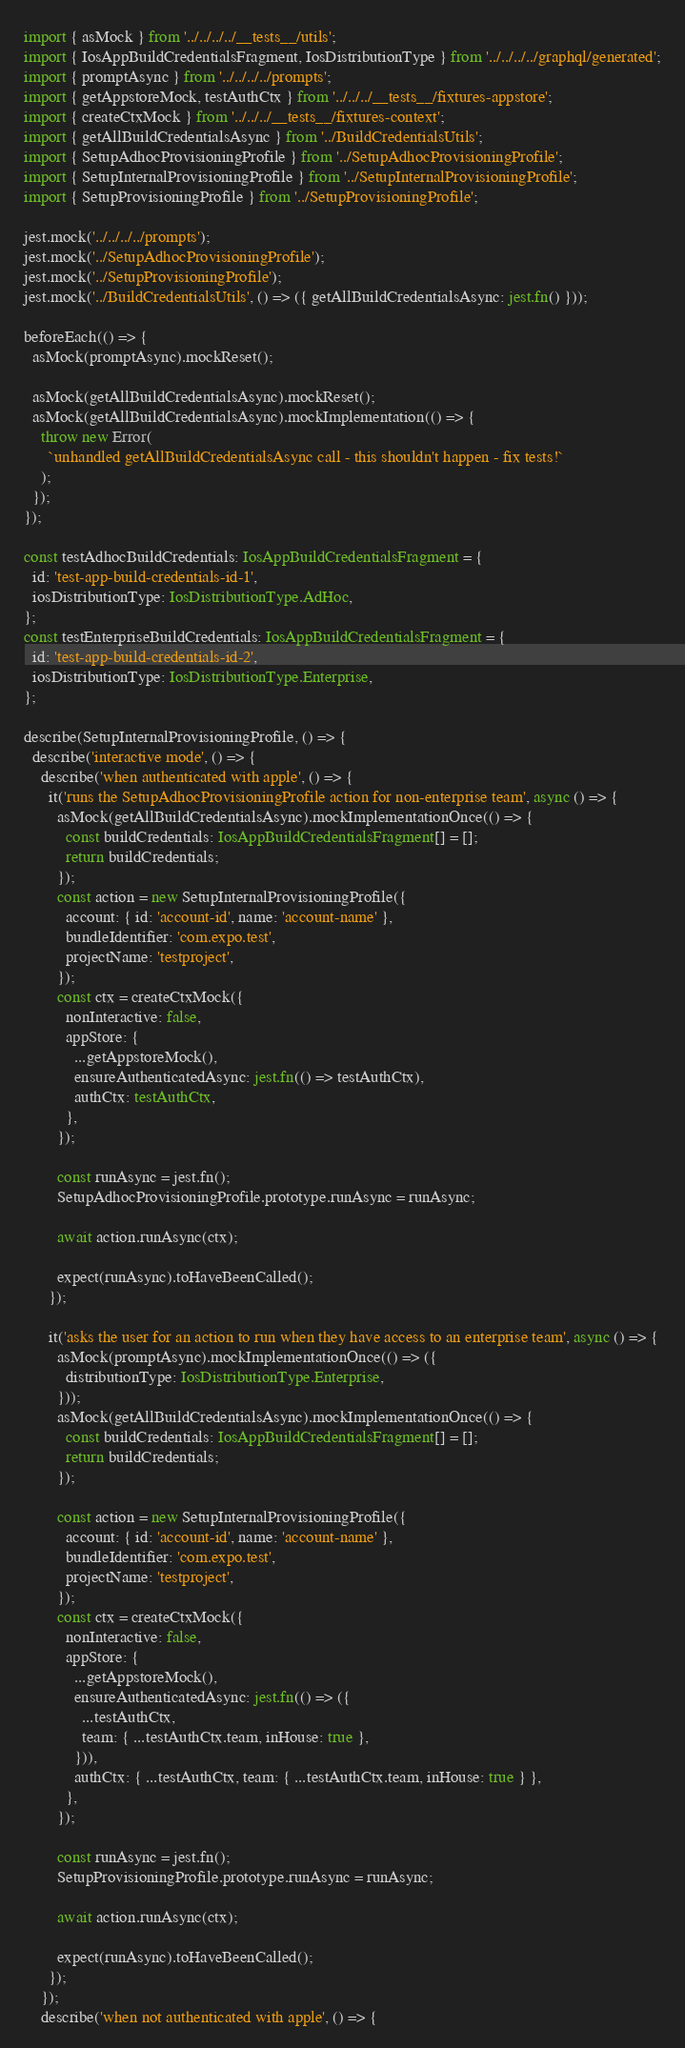Convert code to text. <code><loc_0><loc_0><loc_500><loc_500><_TypeScript_>import { asMock } from '../../../../__tests__/utils';
import { IosAppBuildCredentialsFragment, IosDistributionType } from '../../../../graphql/generated';
import { promptAsync } from '../../../../prompts';
import { getAppstoreMock, testAuthCtx } from '../../../__tests__/fixtures-appstore';
import { createCtxMock } from '../../../__tests__/fixtures-context';
import { getAllBuildCredentialsAsync } from '../BuildCredentialsUtils';
import { SetupAdhocProvisioningProfile } from '../SetupAdhocProvisioningProfile';
import { SetupInternalProvisioningProfile } from '../SetupInternalProvisioningProfile';
import { SetupProvisioningProfile } from '../SetupProvisioningProfile';

jest.mock('../../../../prompts');
jest.mock('../SetupAdhocProvisioningProfile');
jest.mock('../SetupProvisioningProfile');
jest.mock('../BuildCredentialsUtils', () => ({ getAllBuildCredentialsAsync: jest.fn() }));

beforeEach(() => {
  asMock(promptAsync).mockReset();

  asMock(getAllBuildCredentialsAsync).mockReset();
  asMock(getAllBuildCredentialsAsync).mockImplementation(() => {
    throw new Error(
      `unhandled getAllBuildCredentialsAsync call - this shouldn't happen - fix tests!`
    );
  });
});

const testAdhocBuildCredentials: IosAppBuildCredentialsFragment = {
  id: 'test-app-build-credentials-id-1',
  iosDistributionType: IosDistributionType.AdHoc,
};
const testEnterpriseBuildCredentials: IosAppBuildCredentialsFragment = {
  id: 'test-app-build-credentials-id-2',
  iosDistributionType: IosDistributionType.Enterprise,
};

describe(SetupInternalProvisioningProfile, () => {
  describe('interactive mode', () => {
    describe('when authenticated with apple', () => {
      it('runs the SetupAdhocProvisioningProfile action for non-enterprise team', async () => {
        asMock(getAllBuildCredentialsAsync).mockImplementationOnce(() => {
          const buildCredentials: IosAppBuildCredentialsFragment[] = [];
          return buildCredentials;
        });
        const action = new SetupInternalProvisioningProfile({
          account: { id: 'account-id', name: 'account-name' },
          bundleIdentifier: 'com.expo.test',
          projectName: 'testproject',
        });
        const ctx = createCtxMock({
          nonInteractive: false,
          appStore: {
            ...getAppstoreMock(),
            ensureAuthenticatedAsync: jest.fn(() => testAuthCtx),
            authCtx: testAuthCtx,
          },
        });

        const runAsync = jest.fn();
        SetupAdhocProvisioningProfile.prototype.runAsync = runAsync;

        await action.runAsync(ctx);

        expect(runAsync).toHaveBeenCalled();
      });

      it('asks the user for an action to run when they have access to an enterprise team', async () => {
        asMock(promptAsync).mockImplementationOnce(() => ({
          distributionType: IosDistributionType.Enterprise,
        }));
        asMock(getAllBuildCredentialsAsync).mockImplementationOnce(() => {
          const buildCredentials: IosAppBuildCredentialsFragment[] = [];
          return buildCredentials;
        });

        const action = new SetupInternalProvisioningProfile({
          account: { id: 'account-id', name: 'account-name' },
          bundleIdentifier: 'com.expo.test',
          projectName: 'testproject',
        });
        const ctx = createCtxMock({
          nonInteractive: false,
          appStore: {
            ...getAppstoreMock(),
            ensureAuthenticatedAsync: jest.fn(() => ({
              ...testAuthCtx,
              team: { ...testAuthCtx.team, inHouse: true },
            })),
            authCtx: { ...testAuthCtx, team: { ...testAuthCtx.team, inHouse: true } },
          },
        });

        const runAsync = jest.fn();
        SetupProvisioningProfile.prototype.runAsync = runAsync;

        await action.runAsync(ctx);

        expect(runAsync).toHaveBeenCalled();
      });
    });
    describe('when not authenticated with apple', () => {</code> 